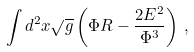<formula> <loc_0><loc_0><loc_500><loc_500>\int d ^ { 2 } x \sqrt { g } \left ( \Phi R - \frac { 2 E ^ { 2 } } { \Phi ^ { 3 } } \right ) \, ,</formula> 